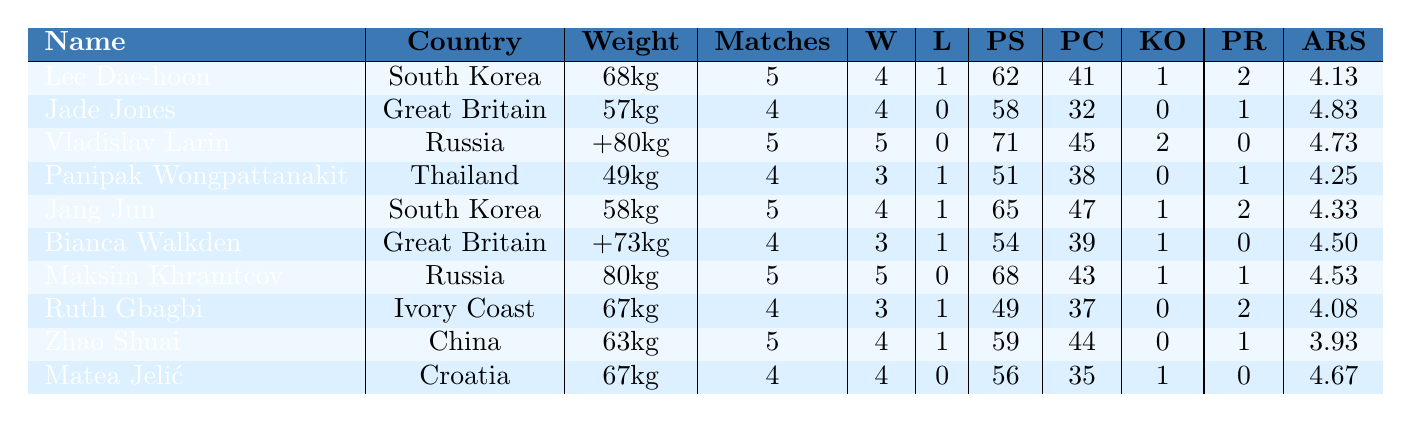What is the name of the athlete who won all their matches? Looking at the table, both Vladislav Larin and Maksim Khramtcov have 5 wins and 0 losses, indicating they won all their matches.
Answer: Vladislav Larin and Maksim Khramtcov Which athlete received the most penalties? Reviewing the penalties received column, Lee Dae-hoon, Jang Jun, and Ruth Gbagbi each received 2 penalties, which is the highest among all athletes.
Answer: Lee Dae-hoon, Jang Jun, and Ruth Gbagbi What is the average score of the athlete from Ivory Coast? The average round score for Ruth Gbagbi, the athlete from Ivory Coast, is 4.08 as per the table.
Answer: 4.08 How many total points were scored by Jade Jones? The row for Jade Jones indicates she scored 58 points during her matches.
Answer: 58 What is the difference in total matches between the athlete from Thailand and the athlete from Russia? Panipak Wongpattanakit from Thailand had 4 matches and Maksim Khramtcov from Russia had 5 matches. The difference is 5 - 4 = 1 match.
Answer: 1 match Which weight class had the highest average round score? To find the highest average round score, we can look at the average round scores of each athlete. Jade Jones had the highest average score of 4.83.
Answer: 57kg (Jade Jones) How many athletes scored fewer points than Lee Dae-hoon? Lee Dae-hoon scored 62 points. By checking all the athletes' scores, we find that 4 athletes scored fewer points (Panipak Wongpattanakit, Bianca Walkden, Ruth Gbagbi, and Zhao Shuai).
Answer: 4 athletes Did any athlete achieve a knockout in every match? By reviewing the knockout column, no athlete achieved knockouts in every match; the most was Vladislav Larin with 2 knockouts in 5 matches.
Answer: No What is the total number of matches played by the athletes from South Korea combined? The total matches played by Lee Dae-hoon (5 matches) and Jang Jun (5 matches) is 5 + 5 = 10 matches.
Answer: 10 matches Which athlete scored the least points and how many? From the points scored column, Ruth Gbagbi scored the least points with a total of 49.
Answer: 49 points 